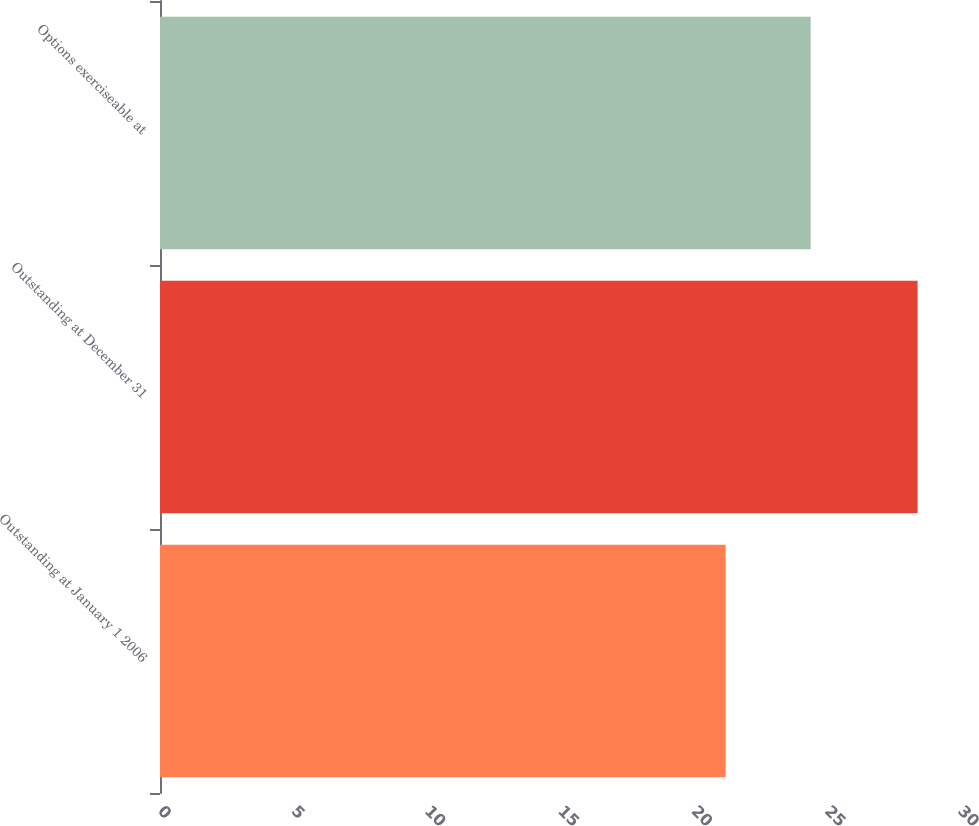<chart> <loc_0><loc_0><loc_500><loc_500><bar_chart><fcel>Outstanding at January 1 2006<fcel>Outstanding at December 31<fcel>Options exerciseable at<nl><fcel>21.21<fcel>28.41<fcel>24.4<nl></chart> 